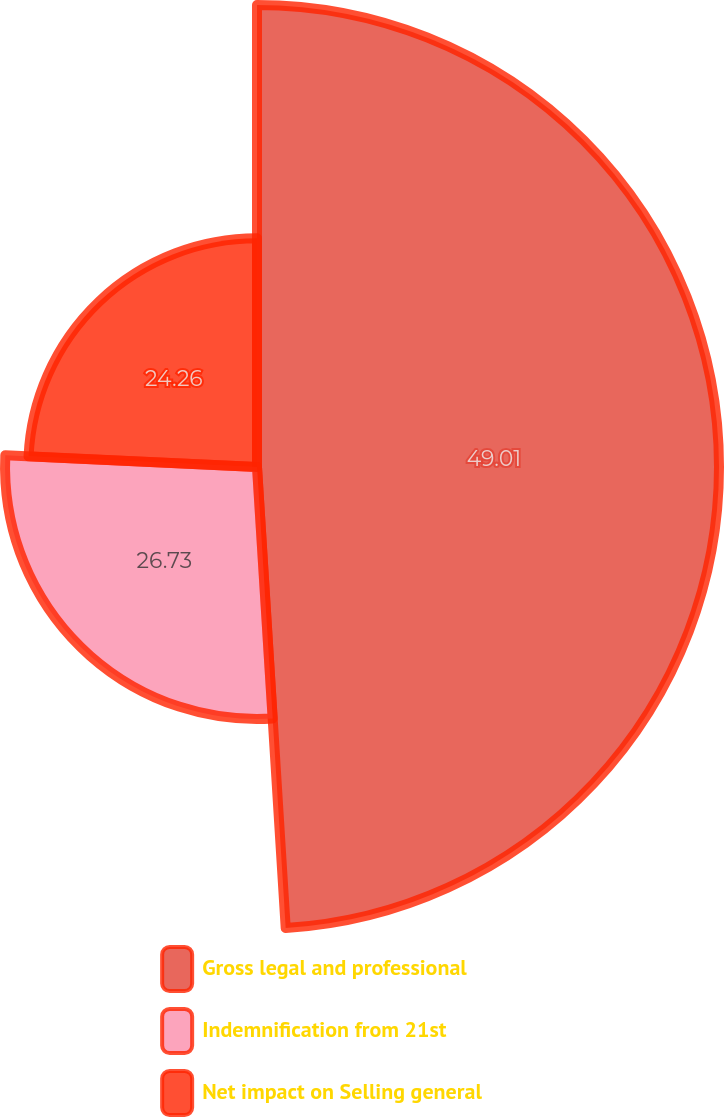Convert chart. <chart><loc_0><loc_0><loc_500><loc_500><pie_chart><fcel>Gross legal and professional<fcel>Indemnification from 21st<fcel>Net impact on Selling general<nl><fcel>49.01%<fcel>26.73%<fcel>24.26%<nl></chart> 